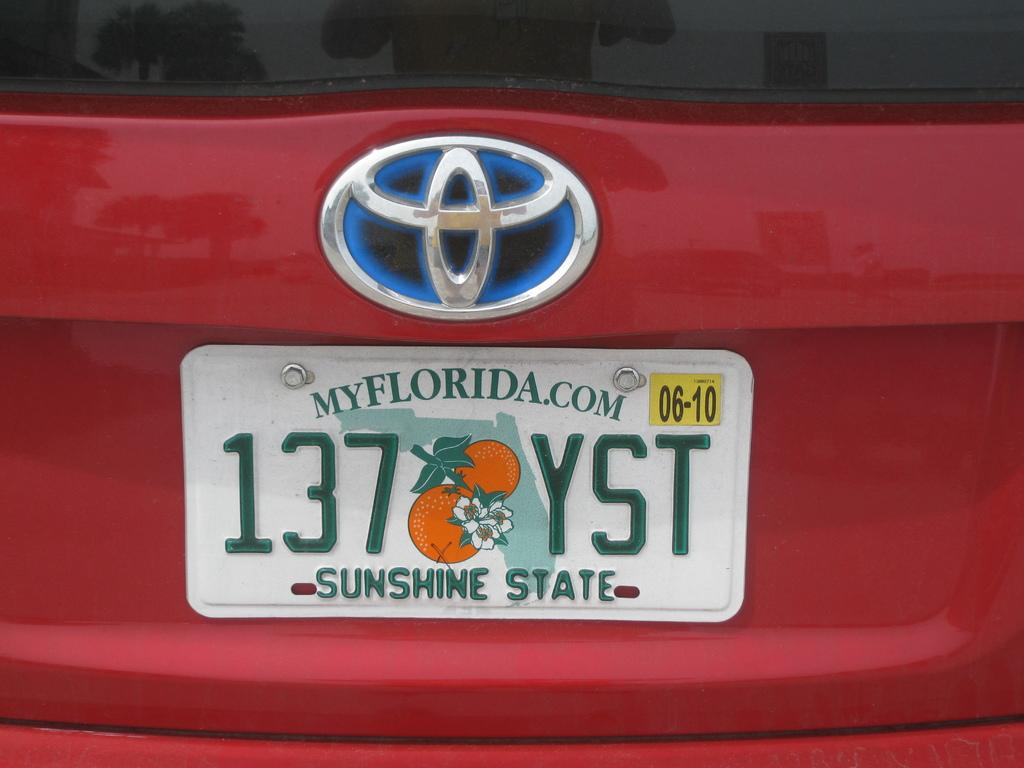<image>
Write a terse but informative summary of the picture. A Toyota license plate is from the Sunshine State AKA Florida. 